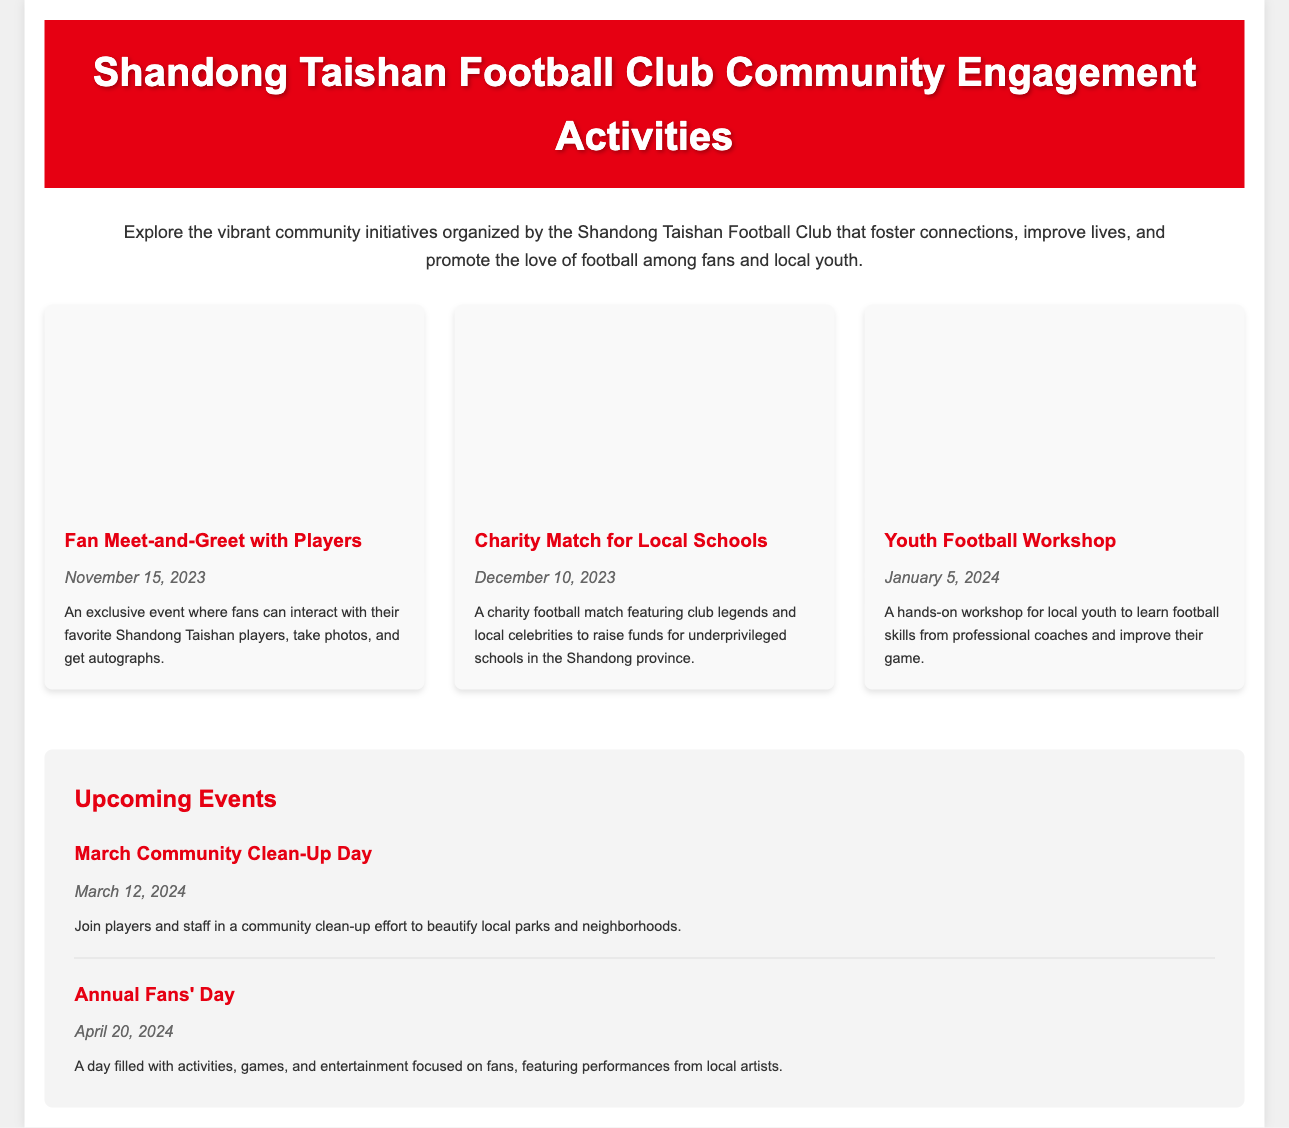What is the title of the document? The title of the document is mentioned in the header of the webpage.
Answer: Shandong Taishan Football Club Community Engagement Activities When is the Fan Meet-and-Greet event? The date for the Fan Meet-and-Greet is listed under the event details.
Answer: November 15, 2023 What charity event is happening on December 10, 2023? The document specifies the name of the charity event associated with that date.
Answer: Charity Match for Local Schools What is the focus of the Youth Football Workshop? The description of the event details what the workshop aims to teach local youth.
Answer: Football skills How many events are featured in the main events section? The number of event blocks present in the events section can be counted.
Answer: 3 What upcoming event is scheduled for March 12, 2024? The next upcoming event is highlighted under the upcoming events section.
Answer: March Community Clean-Up Day Which color is used for the header background in the document? The header's background color is defined in the styling section of the code.
Answer: Red What kind of activities are planned for Annual Fans' Day? The description of the event specifies the type of activities that will take place during the event.
Answer: Activities, games, and entertainment 